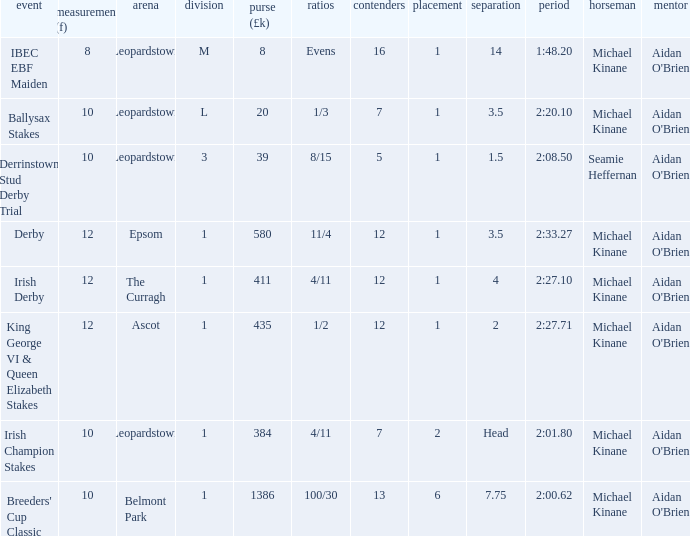Write the full table. {'header': ['event', 'measurement (f)', 'arena', 'division', 'purse (£k)', 'ratios', 'contenders', 'placement', 'separation', 'period', 'horseman', 'mentor'], 'rows': [['IBEC EBF Maiden', '8', 'Leopardstown', 'M', '8', 'Evens', '16', '1', '14', '1:48.20', 'Michael Kinane', "Aidan O'Brien"], ['Ballysax Stakes', '10', 'Leopardstown', 'L', '20', '1/3', '7', '1', '3.5', '2:20.10', 'Michael Kinane', "Aidan O'Brien"], ['Derrinstown Stud Derby Trial', '10', 'Leopardstown', '3', '39', '8/15', '5', '1', '1.5', '2:08.50', 'Seamie Heffernan', "Aidan O'Brien"], ['Derby', '12', 'Epsom', '1', '580', '11/4', '12', '1', '3.5', '2:33.27', 'Michael Kinane', "Aidan O'Brien"], ['Irish Derby', '12', 'The Curragh', '1', '411', '4/11', '12', '1', '4', '2:27.10', 'Michael Kinane', "Aidan O'Brien"], ['King George VI & Queen Elizabeth Stakes', '12', 'Ascot', '1', '435', '1/2', '12', '1', '2', '2:27.71', 'Michael Kinane', "Aidan O'Brien"], ['Irish Champion Stakes', '10', 'Leopardstown', '1', '384', '4/11', '7', '2', 'Head', '2:01.80', 'Michael Kinane', "Aidan O'Brien"], ["Breeders' Cup Classic", '10', 'Belmont Park', '1', '1386', '100/30', '13', '6', '7.75', '2:00.62', 'Michael Kinane', "Aidan O'Brien"]]} Which Margin has a Dist (f) larger than 10, and a Race of king george vi & queen elizabeth stakes? 2.0. 